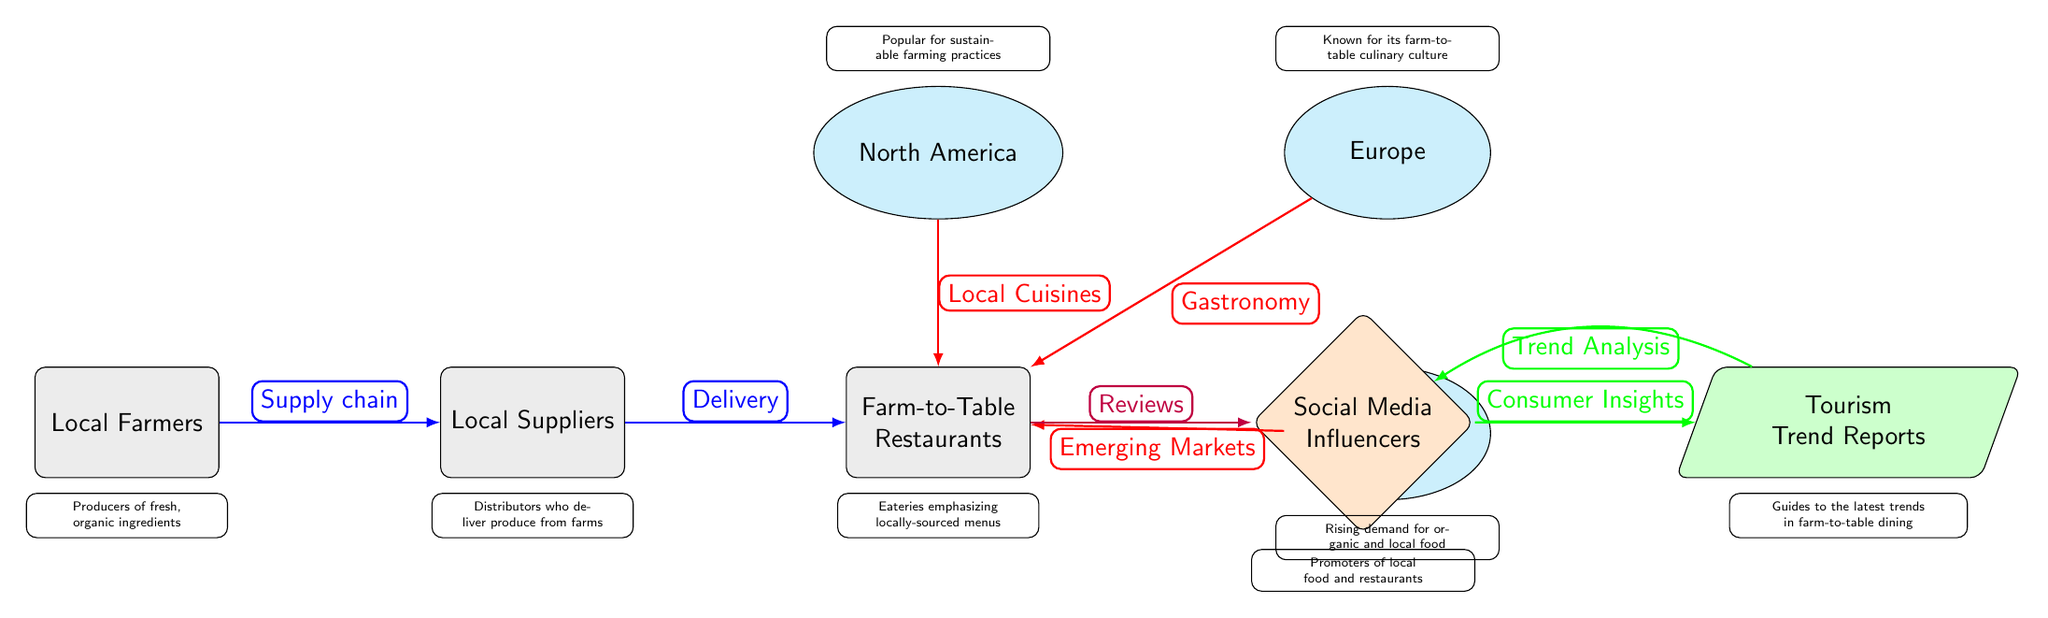What type of entities are connected in this diagram? The diagram connects three types of entities: Local Farmers, Local Suppliers, and Farm-to-Table Restaurants. These are all represented as boxes in the diagram.
Answer: Local Farmers, Local Suppliers, Farm-to-Table Restaurants How many continents are represented in the diagram? The diagram clearly shows three continents: North America, Europe, and Asia, each depicted as ellipses at the top and right sides of the flow.
Answer: Three What are the arrows between the farmers and suppliers labeled as? The diagram indicates that the relationship between Farmers and Suppliers is labeled "Supply chain," which is linked by a blue arrow showing the direction of flow.
Answer: Supply chain What feedback loop is indicated between influencers and trends? The diagram shows an arrow going from trends to influencers labeled as "Trend Analysis," indicating a feedback loop where trends inform influencers.
Answer: Trend Analysis Which continent is associated with "Gastronomy"? The diagram specifies that Europe is associated with "Gastronomy," depicted by a red arrow pointing from Europe to Farm-to-Table Restaurants.
Answer: Europe What is the relationship between social media influencers and tourism trend reports? The diagram shows that social media influencers provide "Consumer Insights" to tourism trend reports, which indicates the flow of information from one to the other.
Answer: Consumer Insights Identify which continent represents emerging markets in relation to farm-to-table restaurants. The diagram connects Asia to Farm-to-Table Restaurants with the label "Emerging Markets," indicating Asia's role in this context.
Answer: Asia What are farm-to-table restaurants emphasized for in this diagram? The diagram highlights that Farm-to-Table Restaurants emphasize locally-sourced menus, denoted in a descriptive text box below the restaurant entity.
Answer: Locally-sourced menus Who are the main promoters of local food in this flow? Social Media Influencers are identified as the main promoters of local food in the diagram, represented as a diamond-shaped node pointing towards Tourism Trend Reports.
Answer: Social Media Influencers 